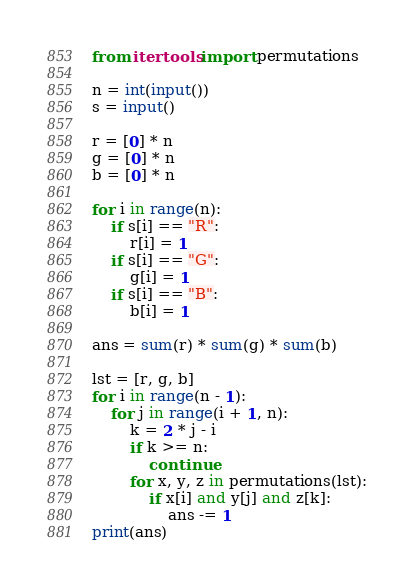<code> <loc_0><loc_0><loc_500><loc_500><_Python_>from itertools import permutations

n = int(input())
s = input()

r = [0] * n
g = [0] * n
b = [0] * n

for i in range(n):
    if s[i] == "R":
        r[i] = 1
    if s[i] == "G":
        g[i] = 1
    if s[i] == "B":
        b[i] = 1

ans = sum(r) * sum(g) * sum(b)

lst = [r, g, b]
for i in range(n - 1):
    for j in range(i + 1, n):
        k = 2 * j - i
        if k >= n:
            continue
        for x, y, z in permutations(lst):
            if x[i] and y[j] and z[k]:
                ans -= 1
print(ans)</code> 